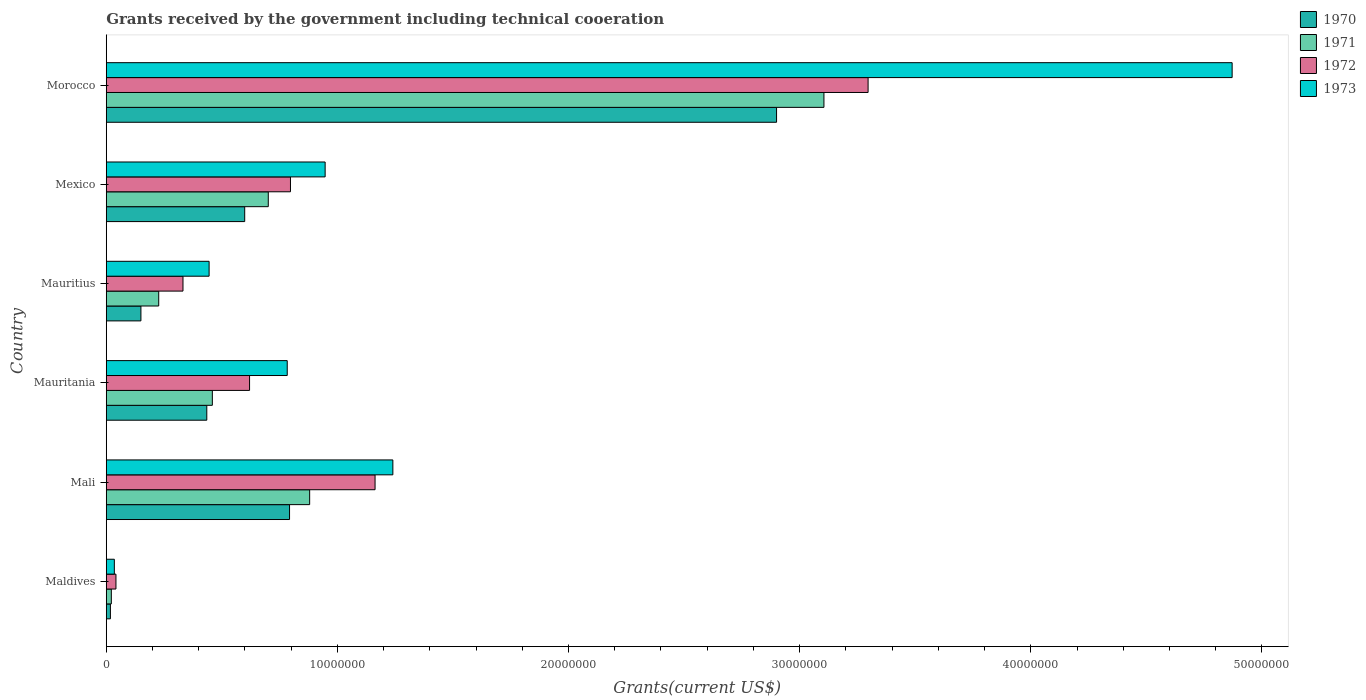How many groups of bars are there?
Offer a terse response. 6. Are the number of bars on each tick of the Y-axis equal?
Keep it short and to the point. Yes. How many bars are there on the 3rd tick from the bottom?
Offer a very short reply. 4. What is the label of the 6th group of bars from the top?
Ensure brevity in your answer.  Maldives. What is the total grants received by the government in 1971 in Mauritius?
Provide a short and direct response. 2.27e+06. Across all countries, what is the maximum total grants received by the government in 1973?
Your answer should be very brief. 4.87e+07. In which country was the total grants received by the government in 1971 maximum?
Provide a short and direct response. Morocco. In which country was the total grants received by the government in 1971 minimum?
Provide a short and direct response. Maldives. What is the total total grants received by the government in 1970 in the graph?
Your answer should be very brief. 4.90e+07. What is the difference between the total grants received by the government in 1971 in Maldives and that in Mauritius?
Keep it short and to the point. -2.05e+06. What is the difference between the total grants received by the government in 1973 in Maldives and the total grants received by the government in 1970 in Mauritius?
Keep it short and to the point. -1.15e+06. What is the average total grants received by the government in 1971 per country?
Provide a succinct answer. 8.99e+06. What is the difference between the total grants received by the government in 1970 and total grants received by the government in 1973 in Maldives?
Your response must be concise. -1.70e+05. What is the ratio of the total grants received by the government in 1973 in Mauritania to that in Mexico?
Keep it short and to the point. 0.83. Is the total grants received by the government in 1972 in Mauritania less than that in Mexico?
Your answer should be compact. Yes. Is the difference between the total grants received by the government in 1970 in Mauritius and Morocco greater than the difference between the total grants received by the government in 1973 in Mauritius and Morocco?
Your response must be concise. Yes. What is the difference between the highest and the second highest total grants received by the government in 1970?
Your response must be concise. 2.11e+07. What is the difference between the highest and the lowest total grants received by the government in 1971?
Offer a very short reply. 3.08e+07. Is it the case that in every country, the sum of the total grants received by the government in 1971 and total grants received by the government in 1972 is greater than the sum of total grants received by the government in 1973 and total grants received by the government in 1970?
Your response must be concise. No. What does the 3rd bar from the top in Mauritius represents?
Provide a succinct answer. 1971. Is it the case that in every country, the sum of the total grants received by the government in 1970 and total grants received by the government in 1973 is greater than the total grants received by the government in 1971?
Offer a terse response. Yes. How many bars are there?
Your answer should be very brief. 24. What is the difference between two consecutive major ticks on the X-axis?
Offer a terse response. 1.00e+07. Are the values on the major ticks of X-axis written in scientific E-notation?
Offer a terse response. No. Where does the legend appear in the graph?
Your answer should be compact. Top right. How many legend labels are there?
Provide a short and direct response. 4. What is the title of the graph?
Offer a terse response. Grants received by the government including technical cooeration. Does "1997" appear as one of the legend labels in the graph?
Make the answer very short. No. What is the label or title of the X-axis?
Provide a succinct answer. Grants(current US$). What is the Grants(current US$) of 1972 in Maldives?
Offer a very short reply. 4.20e+05. What is the Grants(current US$) of 1973 in Maldives?
Give a very brief answer. 3.50e+05. What is the Grants(current US$) of 1970 in Mali?
Ensure brevity in your answer.  7.93e+06. What is the Grants(current US$) in 1971 in Mali?
Give a very brief answer. 8.80e+06. What is the Grants(current US$) in 1972 in Mali?
Offer a very short reply. 1.16e+07. What is the Grants(current US$) of 1973 in Mali?
Ensure brevity in your answer.  1.24e+07. What is the Grants(current US$) in 1970 in Mauritania?
Make the answer very short. 4.35e+06. What is the Grants(current US$) in 1971 in Mauritania?
Keep it short and to the point. 4.59e+06. What is the Grants(current US$) in 1972 in Mauritania?
Ensure brevity in your answer.  6.20e+06. What is the Grants(current US$) in 1973 in Mauritania?
Make the answer very short. 7.83e+06. What is the Grants(current US$) in 1970 in Mauritius?
Offer a terse response. 1.50e+06. What is the Grants(current US$) of 1971 in Mauritius?
Provide a short and direct response. 2.27e+06. What is the Grants(current US$) of 1972 in Mauritius?
Ensure brevity in your answer.  3.32e+06. What is the Grants(current US$) of 1973 in Mauritius?
Your answer should be compact. 4.45e+06. What is the Grants(current US$) of 1970 in Mexico?
Ensure brevity in your answer.  5.99e+06. What is the Grants(current US$) in 1971 in Mexico?
Offer a terse response. 7.01e+06. What is the Grants(current US$) of 1972 in Mexico?
Your answer should be compact. 7.97e+06. What is the Grants(current US$) in 1973 in Mexico?
Your answer should be very brief. 9.47e+06. What is the Grants(current US$) of 1970 in Morocco?
Offer a terse response. 2.90e+07. What is the Grants(current US$) of 1971 in Morocco?
Your response must be concise. 3.10e+07. What is the Grants(current US$) of 1972 in Morocco?
Provide a succinct answer. 3.30e+07. What is the Grants(current US$) in 1973 in Morocco?
Keep it short and to the point. 4.87e+07. Across all countries, what is the maximum Grants(current US$) of 1970?
Make the answer very short. 2.90e+07. Across all countries, what is the maximum Grants(current US$) of 1971?
Offer a terse response. 3.10e+07. Across all countries, what is the maximum Grants(current US$) of 1972?
Your answer should be very brief. 3.30e+07. Across all countries, what is the maximum Grants(current US$) in 1973?
Make the answer very short. 4.87e+07. Across all countries, what is the minimum Grants(current US$) in 1971?
Your answer should be compact. 2.20e+05. Across all countries, what is the minimum Grants(current US$) of 1972?
Keep it short and to the point. 4.20e+05. Across all countries, what is the minimum Grants(current US$) in 1973?
Your answer should be very brief. 3.50e+05. What is the total Grants(current US$) of 1970 in the graph?
Your answer should be compact. 4.90e+07. What is the total Grants(current US$) in 1971 in the graph?
Your answer should be very brief. 5.39e+07. What is the total Grants(current US$) of 1972 in the graph?
Give a very brief answer. 6.25e+07. What is the total Grants(current US$) in 1973 in the graph?
Provide a short and direct response. 8.32e+07. What is the difference between the Grants(current US$) of 1970 in Maldives and that in Mali?
Your answer should be compact. -7.75e+06. What is the difference between the Grants(current US$) in 1971 in Maldives and that in Mali?
Provide a succinct answer. -8.58e+06. What is the difference between the Grants(current US$) of 1972 in Maldives and that in Mali?
Your answer should be very brief. -1.12e+07. What is the difference between the Grants(current US$) in 1973 in Maldives and that in Mali?
Give a very brief answer. -1.20e+07. What is the difference between the Grants(current US$) of 1970 in Maldives and that in Mauritania?
Your answer should be compact. -4.17e+06. What is the difference between the Grants(current US$) in 1971 in Maldives and that in Mauritania?
Provide a succinct answer. -4.37e+06. What is the difference between the Grants(current US$) in 1972 in Maldives and that in Mauritania?
Give a very brief answer. -5.78e+06. What is the difference between the Grants(current US$) of 1973 in Maldives and that in Mauritania?
Provide a succinct answer. -7.48e+06. What is the difference between the Grants(current US$) of 1970 in Maldives and that in Mauritius?
Make the answer very short. -1.32e+06. What is the difference between the Grants(current US$) in 1971 in Maldives and that in Mauritius?
Ensure brevity in your answer.  -2.05e+06. What is the difference between the Grants(current US$) of 1972 in Maldives and that in Mauritius?
Your answer should be very brief. -2.90e+06. What is the difference between the Grants(current US$) of 1973 in Maldives and that in Mauritius?
Offer a very short reply. -4.10e+06. What is the difference between the Grants(current US$) in 1970 in Maldives and that in Mexico?
Offer a terse response. -5.81e+06. What is the difference between the Grants(current US$) in 1971 in Maldives and that in Mexico?
Provide a succinct answer. -6.79e+06. What is the difference between the Grants(current US$) of 1972 in Maldives and that in Mexico?
Your response must be concise. -7.55e+06. What is the difference between the Grants(current US$) in 1973 in Maldives and that in Mexico?
Provide a short and direct response. -9.12e+06. What is the difference between the Grants(current US$) in 1970 in Maldives and that in Morocco?
Provide a succinct answer. -2.88e+07. What is the difference between the Grants(current US$) in 1971 in Maldives and that in Morocco?
Provide a succinct answer. -3.08e+07. What is the difference between the Grants(current US$) in 1972 in Maldives and that in Morocco?
Your answer should be very brief. -3.25e+07. What is the difference between the Grants(current US$) in 1973 in Maldives and that in Morocco?
Make the answer very short. -4.84e+07. What is the difference between the Grants(current US$) in 1970 in Mali and that in Mauritania?
Ensure brevity in your answer.  3.58e+06. What is the difference between the Grants(current US$) in 1971 in Mali and that in Mauritania?
Keep it short and to the point. 4.21e+06. What is the difference between the Grants(current US$) in 1972 in Mali and that in Mauritania?
Provide a succinct answer. 5.43e+06. What is the difference between the Grants(current US$) in 1973 in Mali and that in Mauritania?
Keep it short and to the point. 4.57e+06. What is the difference between the Grants(current US$) in 1970 in Mali and that in Mauritius?
Your response must be concise. 6.43e+06. What is the difference between the Grants(current US$) of 1971 in Mali and that in Mauritius?
Keep it short and to the point. 6.53e+06. What is the difference between the Grants(current US$) in 1972 in Mali and that in Mauritius?
Ensure brevity in your answer.  8.31e+06. What is the difference between the Grants(current US$) of 1973 in Mali and that in Mauritius?
Provide a succinct answer. 7.95e+06. What is the difference between the Grants(current US$) of 1970 in Mali and that in Mexico?
Give a very brief answer. 1.94e+06. What is the difference between the Grants(current US$) in 1971 in Mali and that in Mexico?
Keep it short and to the point. 1.79e+06. What is the difference between the Grants(current US$) in 1972 in Mali and that in Mexico?
Offer a very short reply. 3.66e+06. What is the difference between the Grants(current US$) of 1973 in Mali and that in Mexico?
Make the answer very short. 2.93e+06. What is the difference between the Grants(current US$) in 1970 in Mali and that in Morocco?
Offer a very short reply. -2.11e+07. What is the difference between the Grants(current US$) of 1971 in Mali and that in Morocco?
Provide a succinct answer. -2.22e+07. What is the difference between the Grants(current US$) of 1972 in Mali and that in Morocco?
Your answer should be compact. -2.13e+07. What is the difference between the Grants(current US$) of 1973 in Mali and that in Morocco?
Make the answer very short. -3.63e+07. What is the difference between the Grants(current US$) of 1970 in Mauritania and that in Mauritius?
Provide a short and direct response. 2.85e+06. What is the difference between the Grants(current US$) of 1971 in Mauritania and that in Mauritius?
Give a very brief answer. 2.32e+06. What is the difference between the Grants(current US$) of 1972 in Mauritania and that in Mauritius?
Your answer should be compact. 2.88e+06. What is the difference between the Grants(current US$) in 1973 in Mauritania and that in Mauritius?
Offer a very short reply. 3.38e+06. What is the difference between the Grants(current US$) in 1970 in Mauritania and that in Mexico?
Ensure brevity in your answer.  -1.64e+06. What is the difference between the Grants(current US$) in 1971 in Mauritania and that in Mexico?
Your response must be concise. -2.42e+06. What is the difference between the Grants(current US$) in 1972 in Mauritania and that in Mexico?
Ensure brevity in your answer.  -1.77e+06. What is the difference between the Grants(current US$) in 1973 in Mauritania and that in Mexico?
Provide a succinct answer. -1.64e+06. What is the difference between the Grants(current US$) in 1970 in Mauritania and that in Morocco?
Give a very brief answer. -2.46e+07. What is the difference between the Grants(current US$) of 1971 in Mauritania and that in Morocco?
Make the answer very short. -2.65e+07. What is the difference between the Grants(current US$) of 1972 in Mauritania and that in Morocco?
Ensure brevity in your answer.  -2.68e+07. What is the difference between the Grants(current US$) in 1973 in Mauritania and that in Morocco?
Provide a short and direct response. -4.09e+07. What is the difference between the Grants(current US$) of 1970 in Mauritius and that in Mexico?
Offer a terse response. -4.49e+06. What is the difference between the Grants(current US$) in 1971 in Mauritius and that in Mexico?
Keep it short and to the point. -4.74e+06. What is the difference between the Grants(current US$) in 1972 in Mauritius and that in Mexico?
Provide a short and direct response. -4.65e+06. What is the difference between the Grants(current US$) of 1973 in Mauritius and that in Mexico?
Offer a terse response. -5.02e+06. What is the difference between the Grants(current US$) in 1970 in Mauritius and that in Morocco?
Give a very brief answer. -2.75e+07. What is the difference between the Grants(current US$) in 1971 in Mauritius and that in Morocco?
Your answer should be very brief. -2.88e+07. What is the difference between the Grants(current US$) in 1972 in Mauritius and that in Morocco?
Your answer should be very brief. -2.96e+07. What is the difference between the Grants(current US$) of 1973 in Mauritius and that in Morocco?
Make the answer very short. -4.43e+07. What is the difference between the Grants(current US$) of 1970 in Mexico and that in Morocco?
Provide a succinct answer. -2.30e+07. What is the difference between the Grants(current US$) in 1971 in Mexico and that in Morocco?
Provide a short and direct response. -2.40e+07. What is the difference between the Grants(current US$) of 1972 in Mexico and that in Morocco?
Offer a terse response. -2.50e+07. What is the difference between the Grants(current US$) in 1973 in Mexico and that in Morocco?
Your answer should be compact. -3.92e+07. What is the difference between the Grants(current US$) in 1970 in Maldives and the Grants(current US$) in 1971 in Mali?
Your response must be concise. -8.62e+06. What is the difference between the Grants(current US$) of 1970 in Maldives and the Grants(current US$) of 1972 in Mali?
Ensure brevity in your answer.  -1.14e+07. What is the difference between the Grants(current US$) of 1970 in Maldives and the Grants(current US$) of 1973 in Mali?
Your answer should be very brief. -1.22e+07. What is the difference between the Grants(current US$) of 1971 in Maldives and the Grants(current US$) of 1972 in Mali?
Offer a terse response. -1.14e+07. What is the difference between the Grants(current US$) in 1971 in Maldives and the Grants(current US$) in 1973 in Mali?
Provide a succinct answer. -1.22e+07. What is the difference between the Grants(current US$) of 1972 in Maldives and the Grants(current US$) of 1973 in Mali?
Make the answer very short. -1.20e+07. What is the difference between the Grants(current US$) in 1970 in Maldives and the Grants(current US$) in 1971 in Mauritania?
Your answer should be very brief. -4.41e+06. What is the difference between the Grants(current US$) of 1970 in Maldives and the Grants(current US$) of 1972 in Mauritania?
Provide a short and direct response. -6.02e+06. What is the difference between the Grants(current US$) of 1970 in Maldives and the Grants(current US$) of 1973 in Mauritania?
Provide a short and direct response. -7.65e+06. What is the difference between the Grants(current US$) in 1971 in Maldives and the Grants(current US$) in 1972 in Mauritania?
Your answer should be very brief. -5.98e+06. What is the difference between the Grants(current US$) in 1971 in Maldives and the Grants(current US$) in 1973 in Mauritania?
Your response must be concise. -7.61e+06. What is the difference between the Grants(current US$) in 1972 in Maldives and the Grants(current US$) in 1973 in Mauritania?
Keep it short and to the point. -7.41e+06. What is the difference between the Grants(current US$) of 1970 in Maldives and the Grants(current US$) of 1971 in Mauritius?
Ensure brevity in your answer.  -2.09e+06. What is the difference between the Grants(current US$) of 1970 in Maldives and the Grants(current US$) of 1972 in Mauritius?
Give a very brief answer. -3.14e+06. What is the difference between the Grants(current US$) in 1970 in Maldives and the Grants(current US$) in 1973 in Mauritius?
Your answer should be compact. -4.27e+06. What is the difference between the Grants(current US$) in 1971 in Maldives and the Grants(current US$) in 1972 in Mauritius?
Provide a succinct answer. -3.10e+06. What is the difference between the Grants(current US$) of 1971 in Maldives and the Grants(current US$) of 1973 in Mauritius?
Offer a terse response. -4.23e+06. What is the difference between the Grants(current US$) of 1972 in Maldives and the Grants(current US$) of 1973 in Mauritius?
Make the answer very short. -4.03e+06. What is the difference between the Grants(current US$) of 1970 in Maldives and the Grants(current US$) of 1971 in Mexico?
Keep it short and to the point. -6.83e+06. What is the difference between the Grants(current US$) of 1970 in Maldives and the Grants(current US$) of 1972 in Mexico?
Your answer should be very brief. -7.79e+06. What is the difference between the Grants(current US$) of 1970 in Maldives and the Grants(current US$) of 1973 in Mexico?
Keep it short and to the point. -9.29e+06. What is the difference between the Grants(current US$) in 1971 in Maldives and the Grants(current US$) in 1972 in Mexico?
Offer a terse response. -7.75e+06. What is the difference between the Grants(current US$) of 1971 in Maldives and the Grants(current US$) of 1973 in Mexico?
Your answer should be compact. -9.25e+06. What is the difference between the Grants(current US$) of 1972 in Maldives and the Grants(current US$) of 1973 in Mexico?
Your response must be concise. -9.05e+06. What is the difference between the Grants(current US$) of 1970 in Maldives and the Grants(current US$) of 1971 in Morocco?
Make the answer very short. -3.09e+07. What is the difference between the Grants(current US$) in 1970 in Maldives and the Grants(current US$) in 1972 in Morocco?
Make the answer very short. -3.28e+07. What is the difference between the Grants(current US$) in 1970 in Maldives and the Grants(current US$) in 1973 in Morocco?
Ensure brevity in your answer.  -4.85e+07. What is the difference between the Grants(current US$) in 1971 in Maldives and the Grants(current US$) in 1972 in Morocco?
Offer a terse response. -3.27e+07. What is the difference between the Grants(current US$) of 1971 in Maldives and the Grants(current US$) of 1973 in Morocco?
Your answer should be very brief. -4.85e+07. What is the difference between the Grants(current US$) in 1972 in Maldives and the Grants(current US$) in 1973 in Morocco?
Your response must be concise. -4.83e+07. What is the difference between the Grants(current US$) in 1970 in Mali and the Grants(current US$) in 1971 in Mauritania?
Your answer should be very brief. 3.34e+06. What is the difference between the Grants(current US$) in 1970 in Mali and the Grants(current US$) in 1972 in Mauritania?
Make the answer very short. 1.73e+06. What is the difference between the Grants(current US$) of 1971 in Mali and the Grants(current US$) of 1972 in Mauritania?
Your response must be concise. 2.60e+06. What is the difference between the Grants(current US$) of 1971 in Mali and the Grants(current US$) of 1973 in Mauritania?
Provide a short and direct response. 9.70e+05. What is the difference between the Grants(current US$) of 1972 in Mali and the Grants(current US$) of 1973 in Mauritania?
Your answer should be very brief. 3.80e+06. What is the difference between the Grants(current US$) in 1970 in Mali and the Grants(current US$) in 1971 in Mauritius?
Your answer should be very brief. 5.66e+06. What is the difference between the Grants(current US$) in 1970 in Mali and the Grants(current US$) in 1972 in Mauritius?
Make the answer very short. 4.61e+06. What is the difference between the Grants(current US$) in 1970 in Mali and the Grants(current US$) in 1973 in Mauritius?
Make the answer very short. 3.48e+06. What is the difference between the Grants(current US$) of 1971 in Mali and the Grants(current US$) of 1972 in Mauritius?
Your answer should be compact. 5.48e+06. What is the difference between the Grants(current US$) in 1971 in Mali and the Grants(current US$) in 1973 in Mauritius?
Your response must be concise. 4.35e+06. What is the difference between the Grants(current US$) of 1972 in Mali and the Grants(current US$) of 1973 in Mauritius?
Provide a succinct answer. 7.18e+06. What is the difference between the Grants(current US$) in 1970 in Mali and the Grants(current US$) in 1971 in Mexico?
Provide a short and direct response. 9.20e+05. What is the difference between the Grants(current US$) of 1970 in Mali and the Grants(current US$) of 1972 in Mexico?
Make the answer very short. -4.00e+04. What is the difference between the Grants(current US$) of 1970 in Mali and the Grants(current US$) of 1973 in Mexico?
Offer a terse response. -1.54e+06. What is the difference between the Grants(current US$) of 1971 in Mali and the Grants(current US$) of 1972 in Mexico?
Offer a terse response. 8.30e+05. What is the difference between the Grants(current US$) of 1971 in Mali and the Grants(current US$) of 1973 in Mexico?
Your response must be concise. -6.70e+05. What is the difference between the Grants(current US$) in 1972 in Mali and the Grants(current US$) in 1973 in Mexico?
Your answer should be very brief. 2.16e+06. What is the difference between the Grants(current US$) in 1970 in Mali and the Grants(current US$) in 1971 in Morocco?
Your answer should be compact. -2.31e+07. What is the difference between the Grants(current US$) of 1970 in Mali and the Grants(current US$) of 1972 in Morocco?
Your answer should be compact. -2.50e+07. What is the difference between the Grants(current US$) in 1970 in Mali and the Grants(current US$) in 1973 in Morocco?
Ensure brevity in your answer.  -4.08e+07. What is the difference between the Grants(current US$) in 1971 in Mali and the Grants(current US$) in 1972 in Morocco?
Offer a very short reply. -2.42e+07. What is the difference between the Grants(current US$) of 1971 in Mali and the Grants(current US$) of 1973 in Morocco?
Your answer should be very brief. -3.99e+07. What is the difference between the Grants(current US$) in 1972 in Mali and the Grants(current US$) in 1973 in Morocco?
Offer a very short reply. -3.71e+07. What is the difference between the Grants(current US$) in 1970 in Mauritania and the Grants(current US$) in 1971 in Mauritius?
Offer a terse response. 2.08e+06. What is the difference between the Grants(current US$) in 1970 in Mauritania and the Grants(current US$) in 1972 in Mauritius?
Give a very brief answer. 1.03e+06. What is the difference between the Grants(current US$) in 1970 in Mauritania and the Grants(current US$) in 1973 in Mauritius?
Make the answer very short. -1.00e+05. What is the difference between the Grants(current US$) of 1971 in Mauritania and the Grants(current US$) of 1972 in Mauritius?
Provide a short and direct response. 1.27e+06. What is the difference between the Grants(current US$) in 1971 in Mauritania and the Grants(current US$) in 1973 in Mauritius?
Your response must be concise. 1.40e+05. What is the difference between the Grants(current US$) in 1972 in Mauritania and the Grants(current US$) in 1973 in Mauritius?
Make the answer very short. 1.75e+06. What is the difference between the Grants(current US$) in 1970 in Mauritania and the Grants(current US$) in 1971 in Mexico?
Ensure brevity in your answer.  -2.66e+06. What is the difference between the Grants(current US$) in 1970 in Mauritania and the Grants(current US$) in 1972 in Mexico?
Give a very brief answer. -3.62e+06. What is the difference between the Grants(current US$) of 1970 in Mauritania and the Grants(current US$) of 1973 in Mexico?
Give a very brief answer. -5.12e+06. What is the difference between the Grants(current US$) in 1971 in Mauritania and the Grants(current US$) in 1972 in Mexico?
Give a very brief answer. -3.38e+06. What is the difference between the Grants(current US$) of 1971 in Mauritania and the Grants(current US$) of 1973 in Mexico?
Keep it short and to the point. -4.88e+06. What is the difference between the Grants(current US$) in 1972 in Mauritania and the Grants(current US$) in 1973 in Mexico?
Your answer should be compact. -3.27e+06. What is the difference between the Grants(current US$) of 1970 in Mauritania and the Grants(current US$) of 1971 in Morocco?
Give a very brief answer. -2.67e+07. What is the difference between the Grants(current US$) in 1970 in Mauritania and the Grants(current US$) in 1972 in Morocco?
Keep it short and to the point. -2.86e+07. What is the difference between the Grants(current US$) of 1970 in Mauritania and the Grants(current US$) of 1973 in Morocco?
Give a very brief answer. -4.44e+07. What is the difference between the Grants(current US$) in 1971 in Mauritania and the Grants(current US$) in 1972 in Morocco?
Provide a short and direct response. -2.84e+07. What is the difference between the Grants(current US$) of 1971 in Mauritania and the Grants(current US$) of 1973 in Morocco?
Provide a succinct answer. -4.41e+07. What is the difference between the Grants(current US$) in 1972 in Mauritania and the Grants(current US$) in 1973 in Morocco?
Your answer should be compact. -4.25e+07. What is the difference between the Grants(current US$) in 1970 in Mauritius and the Grants(current US$) in 1971 in Mexico?
Provide a succinct answer. -5.51e+06. What is the difference between the Grants(current US$) in 1970 in Mauritius and the Grants(current US$) in 1972 in Mexico?
Offer a terse response. -6.47e+06. What is the difference between the Grants(current US$) of 1970 in Mauritius and the Grants(current US$) of 1973 in Mexico?
Make the answer very short. -7.97e+06. What is the difference between the Grants(current US$) of 1971 in Mauritius and the Grants(current US$) of 1972 in Mexico?
Give a very brief answer. -5.70e+06. What is the difference between the Grants(current US$) of 1971 in Mauritius and the Grants(current US$) of 1973 in Mexico?
Make the answer very short. -7.20e+06. What is the difference between the Grants(current US$) in 1972 in Mauritius and the Grants(current US$) in 1973 in Mexico?
Make the answer very short. -6.15e+06. What is the difference between the Grants(current US$) in 1970 in Mauritius and the Grants(current US$) in 1971 in Morocco?
Offer a very short reply. -2.96e+07. What is the difference between the Grants(current US$) of 1970 in Mauritius and the Grants(current US$) of 1972 in Morocco?
Your answer should be compact. -3.15e+07. What is the difference between the Grants(current US$) in 1970 in Mauritius and the Grants(current US$) in 1973 in Morocco?
Make the answer very short. -4.72e+07. What is the difference between the Grants(current US$) of 1971 in Mauritius and the Grants(current US$) of 1972 in Morocco?
Provide a short and direct response. -3.07e+07. What is the difference between the Grants(current US$) in 1971 in Mauritius and the Grants(current US$) in 1973 in Morocco?
Give a very brief answer. -4.64e+07. What is the difference between the Grants(current US$) of 1972 in Mauritius and the Grants(current US$) of 1973 in Morocco?
Ensure brevity in your answer.  -4.54e+07. What is the difference between the Grants(current US$) in 1970 in Mexico and the Grants(current US$) in 1971 in Morocco?
Provide a short and direct response. -2.51e+07. What is the difference between the Grants(current US$) of 1970 in Mexico and the Grants(current US$) of 1972 in Morocco?
Offer a terse response. -2.70e+07. What is the difference between the Grants(current US$) in 1970 in Mexico and the Grants(current US$) in 1973 in Morocco?
Your answer should be compact. -4.27e+07. What is the difference between the Grants(current US$) of 1971 in Mexico and the Grants(current US$) of 1972 in Morocco?
Your answer should be very brief. -2.60e+07. What is the difference between the Grants(current US$) in 1971 in Mexico and the Grants(current US$) in 1973 in Morocco?
Give a very brief answer. -4.17e+07. What is the difference between the Grants(current US$) of 1972 in Mexico and the Grants(current US$) of 1973 in Morocco?
Provide a short and direct response. -4.07e+07. What is the average Grants(current US$) in 1970 per country?
Your response must be concise. 8.16e+06. What is the average Grants(current US$) of 1971 per country?
Make the answer very short. 8.99e+06. What is the average Grants(current US$) of 1972 per country?
Your response must be concise. 1.04e+07. What is the average Grants(current US$) in 1973 per country?
Your response must be concise. 1.39e+07. What is the difference between the Grants(current US$) in 1970 and Grants(current US$) in 1972 in Maldives?
Offer a terse response. -2.40e+05. What is the difference between the Grants(current US$) of 1970 and Grants(current US$) of 1973 in Maldives?
Offer a terse response. -1.70e+05. What is the difference between the Grants(current US$) in 1971 and Grants(current US$) in 1972 in Maldives?
Your answer should be very brief. -2.00e+05. What is the difference between the Grants(current US$) in 1971 and Grants(current US$) in 1973 in Maldives?
Your answer should be compact. -1.30e+05. What is the difference between the Grants(current US$) of 1970 and Grants(current US$) of 1971 in Mali?
Keep it short and to the point. -8.70e+05. What is the difference between the Grants(current US$) of 1970 and Grants(current US$) of 1972 in Mali?
Provide a succinct answer. -3.70e+06. What is the difference between the Grants(current US$) in 1970 and Grants(current US$) in 1973 in Mali?
Ensure brevity in your answer.  -4.47e+06. What is the difference between the Grants(current US$) of 1971 and Grants(current US$) of 1972 in Mali?
Provide a short and direct response. -2.83e+06. What is the difference between the Grants(current US$) of 1971 and Grants(current US$) of 1973 in Mali?
Make the answer very short. -3.60e+06. What is the difference between the Grants(current US$) in 1972 and Grants(current US$) in 1973 in Mali?
Your answer should be very brief. -7.70e+05. What is the difference between the Grants(current US$) of 1970 and Grants(current US$) of 1971 in Mauritania?
Make the answer very short. -2.40e+05. What is the difference between the Grants(current US$) of 1970 and Grants(current US$) of 1972 in Mauritania?
Your answer should be very brief. -1.85e+06. What is the difference between the Grants(current US$) of 1970 and Grants(current US$) of 1973 in Mauritania?
Make the answer very short. -3.48e+06. What is the difference between the Grants(current US$) in 1971 and Grants(current US$) in 1972 in Mauritania?
Keep it short and to the point. -1.61e+06. What is the difference between the Grants(current US$) in 1971 and Grants(current US$) in 1973 in Mauritania?
Provide a succinct answer. -3.24e+06. What is the difference between the Grants(current US$) of 1972 and Grants(current US$) of 1973 in Mauritania?
Your response must be concise. -1.63e+06. What is the difference between the Grants(current US$) of 1970 and Grants(current US$) of 1971 in Mauritius?
Provide a succinct answer. -7.70e+05. What is the difference between the Grants(current US$) of 1970 and Grants(current US$) of 1972 in Mauritius?
Your answer should be compact. -1.82e+06. What is the difference between the Grants(current US$) of 1970 and Grants(current US$) of 1973 in Mauritius?
Offer a very short reply. -2.95e+06. What is the difference between the Grants(current US$) in 1971 and Grants(current US$) in 1972 in Mauritius?
Provide a short and direct response. -1.05e+06. What is the difference between the Grants(current US$) in 1971 and Grants(current US$) in 1973 in Mauritius?
Your response must be concise. -2.18e+06. What is the difference between the Grants(current US$) of 1972 and Grants(current US$) of 1973 in Mauritius?
Provide a succinct answer. -1.13e+06. What is the difference between the Grants(current US$) of 1970 and Grants(current US$) of 1971 in Mexico?
Give a very brief answer. -1.02e+06. What is the difference between the Grants(current US$) of 1970 and Grants(current US$) of 1972 in Mexico?
Keep it short and to the point. -1.98e+06. What is the difference between the Grants(current US$) of 1970 and Grants(current US$) of 1973 in Mexico?
Provide a short and direct response. -3.48e+06. What is the difference between the Grants(current US$) in 1971 and Grants(current US$) in 1972 in Mexico?
Offer a very short reply. -9.60e+05. What is the difference between the Grants(current US$) in 1971 and Grants(current US$) in 1973 in Mexico?
Make the answer very short. -2.46e+06. What is the difference between the Grants(current US$) of 1972 and Grants(current US$) of 1973 in Mexico?
Keep it short and to the point. -1.50e+06. What is the difference between the Grants(current US$) of 1970 and Grants(current US$) of 1971 in Morocco?
Your response must be concise. -2.05e+06. What is the difference between the Grants(current US$) of 1970 and Grants(current US$) of 1972 in Morocco?
Offer a very short reply. -3.96e+06. What is the difference between the Grants(current US$) in 1970 and Grants(current US$) in 1973 in Morocco?
Make the answer very short. -1.97e+07. What is the difference between the Grants(current US$) in 1971 and Grants(current US$) in 1972 in Morocco?
Provide a short and direct response. -1.91e+06. What is the difference between the Grants(current US$) of 1971 and Grants(current US$) of 1973 in Morocco?
Give a very brief answer. -1.77e+07. What is the difference between the Grants(current US$) of 1972 and Grants(current US$) of 1973 in Morocco?
Ensure brevity in your answer.  -1.58e+07. What is the ratio of the Grants(current US$) of 1970 in Maldives to that in Mali?
Provide a short and direct response. 0.02. What is the ratio of the Grants(current US$) in 1971 in Maldives to that in Mali?
Give a very brief answer. 0.03. What is the ratio of the Grants(current US$) of 1972 in Maldives to that in Mali?
Your answer should be compact. 0.04. What is the ratio of the Grants(current US$) of 1973 in Maldives to that in Mali?
Offer a very short reply. 0.03. What is the ratio of the Grants(current US$) in 1970 in Maldives to that in Mauritania?
Your answer should be very brief. 0.04. What is the ratio of the Grants(current US$) in 1971 in Maldives to that in Mauritania?
Ensure brevity in your answer.  0.05. What is the ratio of the Grants(current US$) in 1972 in Maldives to that in Mauritania?
Provide a succinct answer. 0.07. What is the ratio of the Grants(current US$) in 1973 in Maldives to that in Mauritania?
Keep it short and to the point. 0.04. What is the ratio of the Grants(current US$) in 1970 in Maldives to that in Mauritius?
Provide a succinct answer. 0.12. What is the ratio of the Grants(current US$) of 1971 in Maldives to that in Mauritius?
Your answer should be compact. 0.1. What is the ratio of the Grants(current US$) in 1972 in Maldives to that in Mauritius?
Your answer should be very brief. 0.13. What is the ratio of the Grants(current US$) of 1973 in Maldives to that in Mauritius?
Your answer should be very brief. 0.08. What is the ratio of the Grants(current US$) of 1970 in Maldives to that in Mexico?
Give a very brief answer. 0.03. What is the ratio of the Grants(current US$) in 1971 in Maldives to that in Mexico?
Provide a short and direct response. 0.03. What is the ratio of the Grants(current US$) of 1972 in Maldives to that in Mexico?
Your answer should be very brief. 0.05. What is the ratio of the Grants(current US$) of 1973 in Maldives to that in Mexico?
Your answer should be very brief. 0.04. What is the ratio of the Grants(current US$) of 1970 in Maldives to that in Morocco?
Provide a succinct answer. 0.01. What is the ratio of the Grants(current US$) in 1971 in Maldives to that in Morocco?
Your answer should be very brief. 0.01. What is the ratio of the Grants(current US$) in 1972 in Maldives to that in Morocco?
Ensure brevity in your answer.  0.01. What is the ratio of the Grants(current US$) of 1973 in Maldives to that in Morocco?
Your response must be concise. 0.01. What is the ratio of the Grants(current US$) of 1970 in Mali to that in Mauritania?
Offer a very short reply. 1.82. What is the ratio of the Grants(current US$) in 1971 in Mali to that in Mauritania?
Make the answer very short. 1.92. What is the ratio of the Grants(current US$) of 1972 in Mali to that in Mauritania?
Give a very brief answer. 1.88. What is the ratio of the Grants(current US$) of 1973 in Mali to that in Mauritania?
Keep it short and to the point. 1.58. What is the ratio of the Grants(current US$) of 1970 in Mali to that in Mauritius?
Your answer should be compact. 5.29. What is the ratio of the Grants(current US$) in 1971 in Mali to that in Mauritius?
Make the answer very short. 3.88. What is the ratio of the Grants(current US$) in 1972 in Mali to that in Mauritius?
Provide a succinct answer. 3.5. What is the ratio of the Grants(current US$) of 1973 in Mali to that in Mauritius?
Ensure brevity in your answer.  2.79. What is the ratio of the Grants(current US$) in 1970 in Mali to that in Mexico?
Give a very brief answer. 1.32. What is the ratio of the Grants(current US$) of 1971 in Mali to that in Mexico?
Provide a succinct answer. 1.26. What is the ratio of the Grants(current US$) of 1972 in Mali to that in Mexico?
Give a very brief answer. 1.46. What is the ratio of the Grants(current US$) in 1973 in Mali to that in Mexico?
Give a very brief answer. 1.31. What is the ratio of the Grants(current US$) in 1970 in Mali to that in Morocco?
Your answer should be very brief. 0.27. What is the ratio of the Grants(current US$) in 1971 in Mali to that in Morocco?
Provide a succinct answer. 0.28. What is the ratio of the Grants(current US$) in 1972 in Mali to that in Morocco?
Your answer should be very brief. 0.35. What is the ratio of the Grants(current US$) of 1973 in Mali to that in Morocco?
Ensure brevity in your answer.  0.25. What is the ratio of the Grants(current US$) of 1971 in Mauritania to that in Mauritius?
Provide a short and direct response. 2.02. What is the ratio of the Grants(current US$) in 1972 in Mauritania to that in Mauritius?
Your answer should be very brief. 1.87. What is the ratio of the Grants(current US$) of 1973 in Mauritania to that in Mauritius?
Make the answer very short. 1.76. What is the ratio of the Grants(current US$) of 1970 in Mauritania to that in Mexico?
Your response must be concise. 0.73. What is the ratio of the Grants(current US$) of 1971 in Mauritania to that in Mexico?
Provide a short and direct response. 0.65. What is the ratio of the Grants(current US$) in 1972 in Mauritania to that in Mexico?
Make the answer very short. 0.78. What is the ratio of the Grants(current US$) of 1973 in Mauritania to that in Mexico?
Provide a short and direct response. 0.83. What is the ratio of the Grants(current US$) of 1971 in Mauritania to that in Morocco?
Give a very brief answer. 0.15. What is the ratio of the Grants(current US$) in 1972 in Mauritania to that in Morocco?
Provide a succinct answer. 0.19. What is the ratio of the Grants(current US$) in 1973 in Mauritania to that in Morocco?
Your response must be concise. 0.16. What is the ratio of the Grants(current US$) of 1970 in Mauritius to that in Mexico?
Provide a succinct answer. 0.25. What is the ratio of the Grants(current US$) in 1971 in Mauritius to that in Mexico?
Offer a terse response. 0.32. What is the ratio of the Grants(current US$) in 1972 in Mauritius to that in Mexico?
Give a very brief answer. 0.42. What is the ratio of the Grants(current US$) in 1973 in Mauritius to that in Mexico?
Make the answer very short. 0.47. What is the ratio of the Grants(current US$) in 1970 in Mauritius to that in Morocco?
Give a very brief answer. 0.05. What is the ratio of the Grants(current US$) in 1971 in Mauritius to that in Morocco?
Offer a very short reply. 0.07. What is the ratio of the Grants(current US$) in 1972 in Mauritius to that in Morocco?
Offer a terse response. 0.1. What is the ratio of the Grants(current US$) in 1973 in Mauritius to that in Morocco?
Provide a short and direct response. 0.09. What is the ratio of the Grants(current US$) in 1970 in Mexico to that in Morocco?
Make the answer very short. 0.21. What is the ratio of the Grants(current US$) of 1971 in Mexico to that in Morocco?
Provide a short and direct response. 0.23. What is the ratio of the Grants(current US$) in 1972 in Mexico to that in Morocco?
Keep it short and to the point. 0.24. What is the ratio of the Grants(current US$) in 1973 in Mexico to that in Morocco?
Offer a terse response. 0.19. What is the difference between the highest and the second highest Grants(current US$) in 1970?
Offer a terse response. 2.11e+07. What is the difference between the highest and the second highest Grants(current US$) of 1971?
Offer a very short reply. 2.22e+07. What is the difference between the highest and the second highest Grants(current US$) in 1972?
Your answer should be compact. 2.13e+07. What is the difference between the highest and the second highest Grants(current US$) of 1973?
Your answer should be very brief. 3.63e+07. What is the difference between the highest and the lowest Grants(current US$) of 1970?
Ensure brevity in your answer.  2.88e+07. What is the difference between the highest and the lowest Grants(current US$) in 1971?
Your answer should be compact. 3.08e+07. What is the difference between the highest and the lowest Grants(current US$) of 1972?
Offer a terse response. 3.25e+07. What is the difference between the highest and the lowest Grants(current US$) in 1973?
Provide a succinct answer. 4.84e+07. 